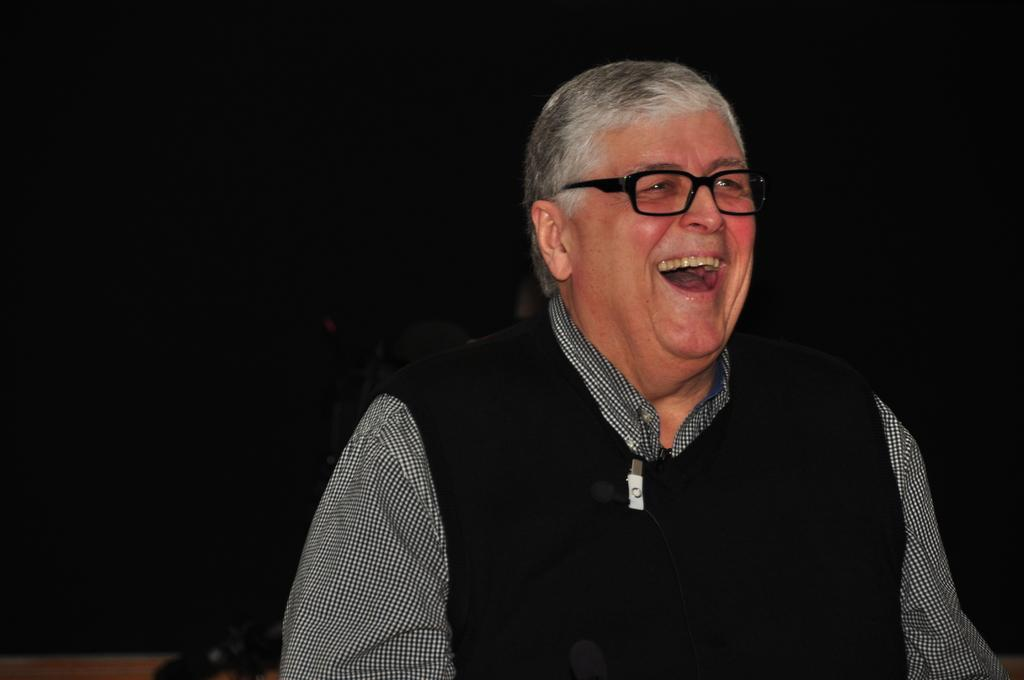What is the main subject of the image? There is a man in the image. What is the man doing in the image? The man is laughing. What is the man wearing in the image? The man is wearing a black color sweater. How many people are in the group with the man in the image? There is no group present in the image; it only features the man. What is the relationship between the man and his mother in the image? There is no mother present in the image, and the man's relationship with his mother cannot be determined from the image. 